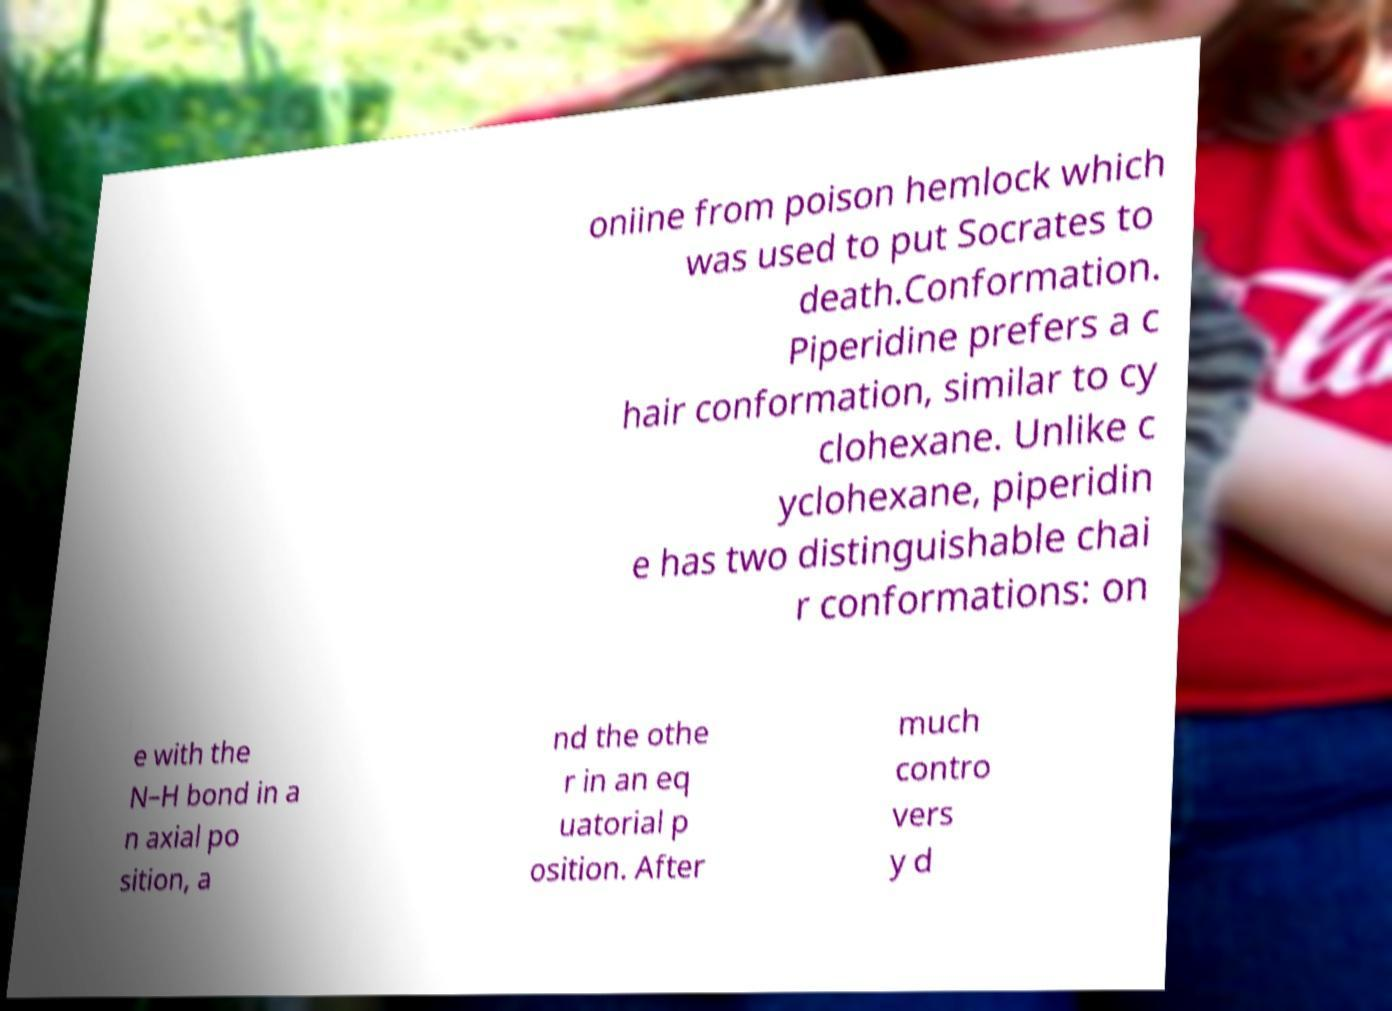I need the written content from this picture converted into text. Can you do that? oniine from poison hemlock which was used to put Socrates to death.Conformation. Piperidine prefers a c hair conformation, similar to cy clohexane. Unlike c yclohexane, piperidin e has two distinguishable chai r conformations: on e with the N–H bond in a n axial po sition, a nd the othe r in an eq uatorial p osition. After much contro vers y d 